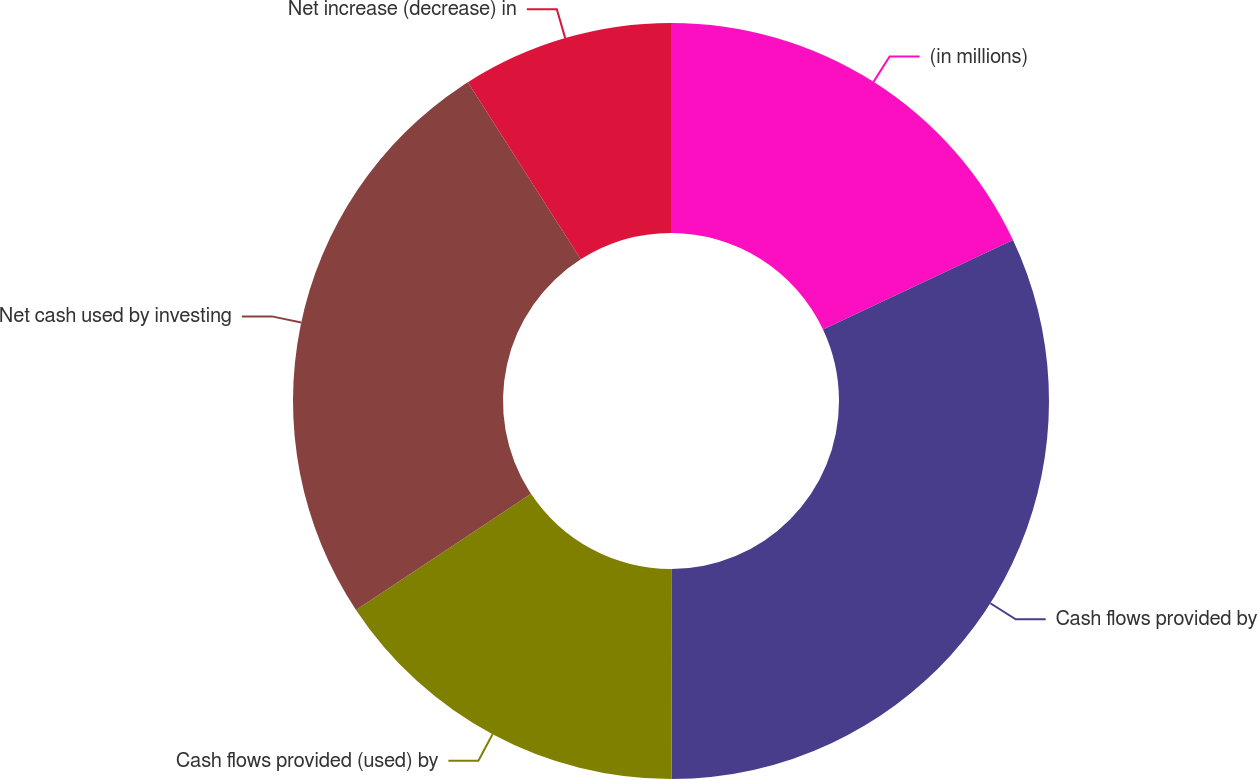<chart> <loc_0><loc_0><loc_500><loc_500><pie_chart><fcel>(in millions)<fcel>Cash flows provided by<fcel>Cash flows provided (used) by<fcel>Net cash used by investing<fcel>Net increase (decrease) in<nl><fcel>18.0%<fcel>31.97%<fcel>15.71%<fcel>25.29%<fcel>9.03%<nl></chart> 